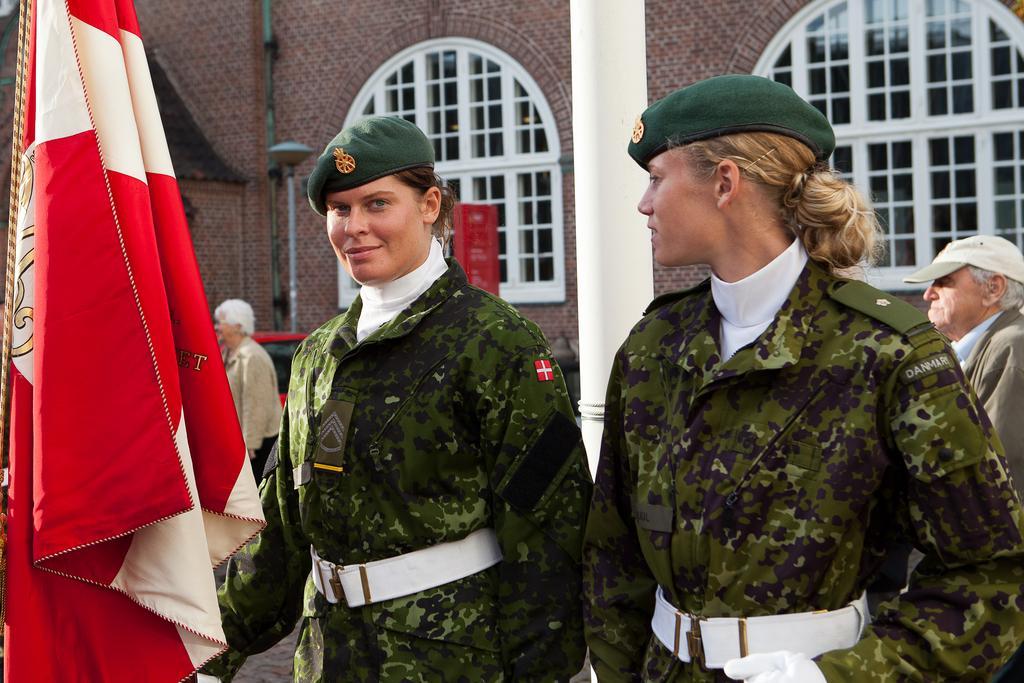How would you summarize this image in a sentence or two? In the foreground of this image, there are two women wearing green color coats and white color belt are standing in front of a flag which is on the left side of the image. In the background, there is a building, pillar, two persons and a red vehicle. 